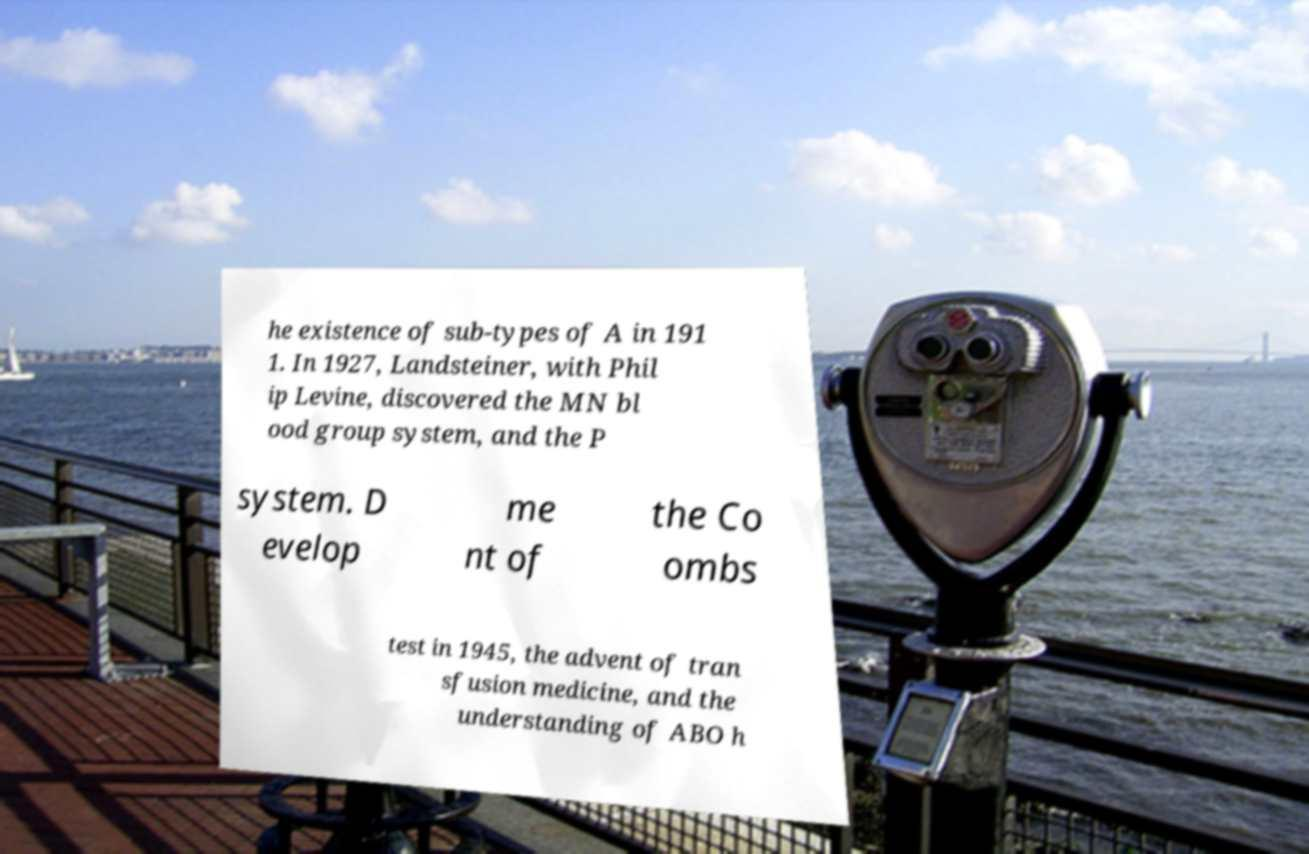Please identify and transcribe the text found in this image. he existence of sub-types of A in 191 1. In 1927, Landsteiner, with Phil ip Levine, discovered the MN bl ood group system, and the P system. D evelop me nt of the Co ombs test in 1945, the advent of tran sfusion medicine, and the understanding of ABO h 